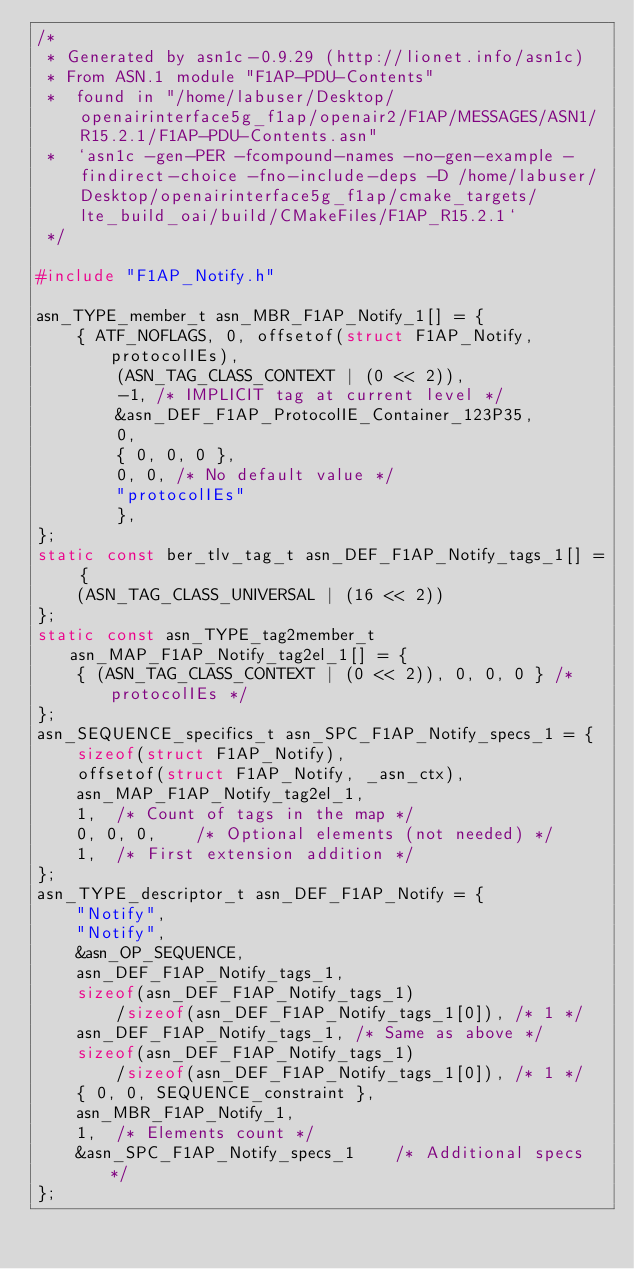<code> <loc_0><loc_0><loc_500><loc_500><_C_>/*
 * Generated by asn1c-0.9.29 (http://lionet.info/asn1c)
 * From ASN.1 module "F1AP-PDU-Contents"
 * 	found in "/home/labuser/Desktop/openairinterface5g_f1ap/openair2/F1AP/MESSAGES/ASN1/R15.2.1/F1AP-PDU-Contents.asn"
 * 	`asn1c -gen-PER -fcompound-names -no-gen-example -findirect-choice -fno-include-deps -D /home/labuser/Desktop/openairinterface5g_f1ap/cmake_targets/lte_build_oai/build/CMakeFiles/F1AP_R15.2.1`
 */

#include "F1AP_Notify.h"

asn_TYPE_member_t asn_MBR_F1AP_Notify_1[] = {
	{ ATF_NOFLAGS, 0, offsetof(struct F1AP_Notify, protocolIEs),
		(ASN_TAG_CLASS_CONTEXT | (0 << 2)),
		-1,	/* IMPLICIT tag at current level */
		&asn_DEF_F1AP_ProtocolIE_Container_123P35,
		0,
		{ 0, 0, 0 },
		0, 0, /* No default value */
		"protocolIEs"
		},
};
static const ber_tlv_tag_t asn_DEF_F1AP_Notify_tags_1[] = {
	(ASN_TAG_CLASS_UNIVERSAL | (16 << 2))
};
static const asn_TYPE_tag2member_t asn_MAP_F1AP_Notify_tag2el_1[] = {
    { (ASN_TAG_CLASS_CONTEXT | (0 << 2)), 0, 0, 0 } /* protocolIEs */
};
asn_SEQUENCE_specifics_t asn_SPC_F1AP_Notify_specs_1 = {
	sizeof(struct F1AP_Notify),
	offsetof(struct F1AP_Notify, _asn_ctx),
	asn_MAP_F1AP_Notify_tag2el_1,
	1,	/* Count of tags in the map */
	0, 0, 0,	/* Optional elements (not needed) */
	1,	/* First extension addition */
};
asn_TYPE_descriptor_t asn_DEF_F1AP_Notify = {
	"Notify",
	"Notify",
	&asn_OP_SEQUENCE,
	asn_DEF_F1AP_Notify_tags_1,
	sizeof(asn_DEF_F1AP_Notify_tags_1)
		/sizeof(asn_DEF_F1AP_Notify_tags_1[0]), /* 1 */
	asn_DEF_F1AP_Notify_tags_1,	/* Same as above */
	sizeof(asn_DEF_F1AP_Notify_tags_1)
		/sizeof(asn_DEF_F1AP_Notify_tags_1[0]), /* 1 */
	{ 0, 0, SEQUENCE_constraint },
	asn_MBR_F1AP_Notify_1,
	1,	/* Elements count */
	&asn_SPC_F1AP_Notify_specs_1	/* Additional specs */
};

</code> 